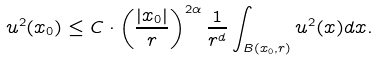Convert formula to latex. <formula><loc_0><loc_0><loc_500><loc_500>u ^ { 2 } ( x _ { 0 } ) \leq C \cdot \left ( \frac { | x _ { 0 } | } { r } \right ) ^ { 2 \alpha } \frac { 1 } { r ^ { d } } \int _ { B ( x _ { 0 } , r ) } u ^ { 2 } ( x ) d x .</formula> 